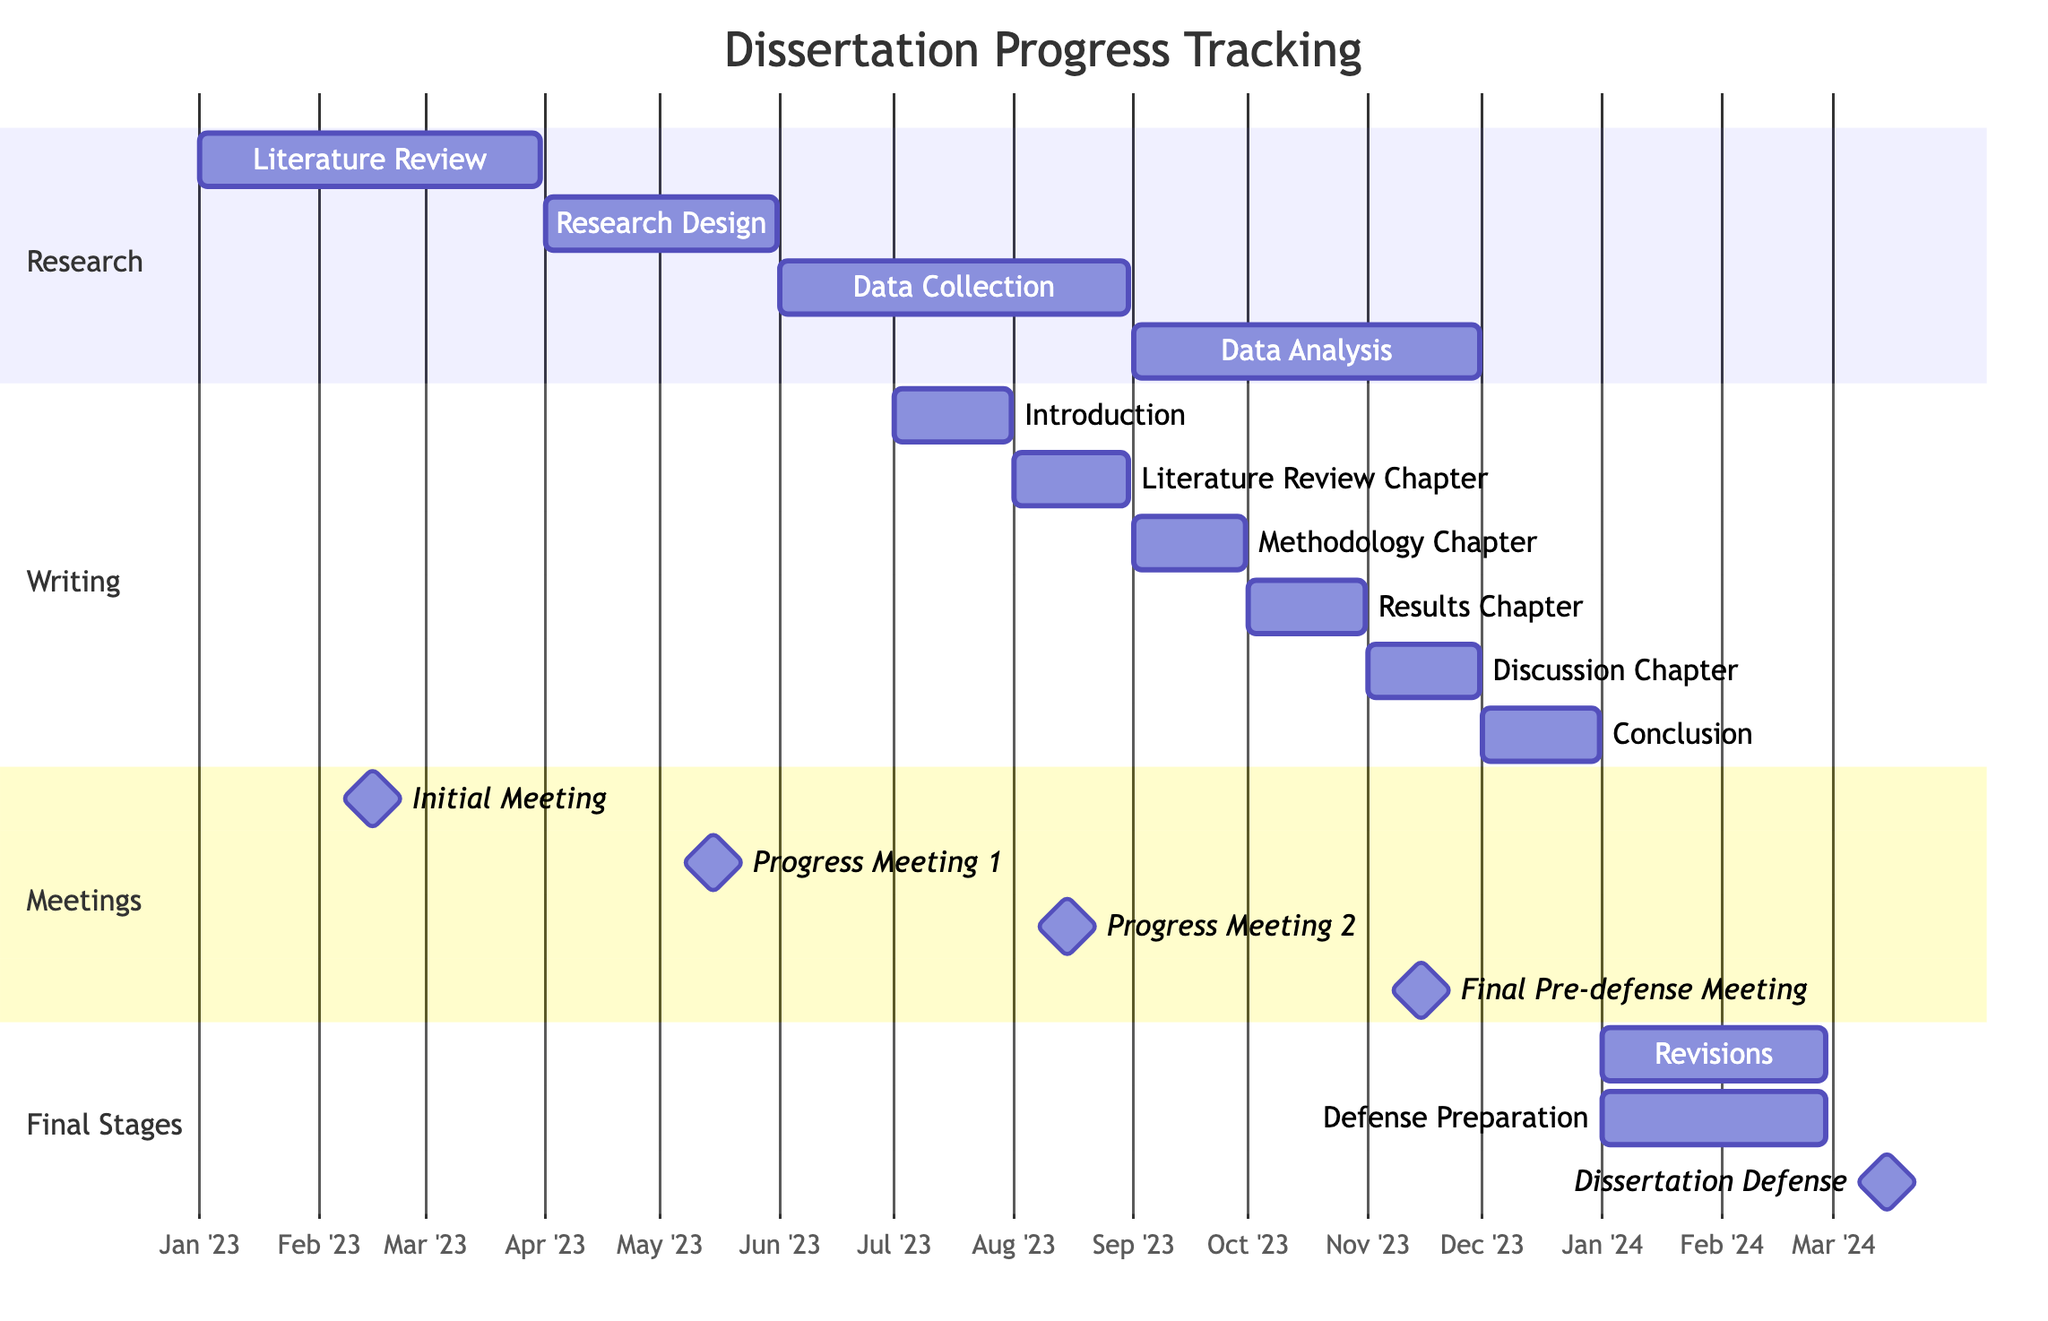What is the end date for the Data Analysis phase? The Data Analysis phase is represented in the Gantt chart, and it begins on September 1, 2023, and ends on November 30, 2023.
Answer: November 30, 2023 How many chapters are being drafted in total? The Gantt chart lists six subtasks under "Drafting Chapters." They are the Introduction, Literature Review Chapter, Methodology Chapter, Results Chapter, Discussion Chapter, and Conclusion, which totals to six chapters.
Answer: 6 When will the Final Pre-defense Meeting occur? The Gantt chart shows the date for the Final Pre-defense Meeting as November 15, 2023, which is indicated as a milestone.
Answer: November 15, 2023 Which phase overlaps with Data Collection? Observing the Gantt chart, the "Drafting Chapters" phase starts on July 1, 2023, and continues until December 31, 2023, overlapping with Data Collection, which spans from June 1, 2023, to August 31, 2023. Thus, the chapter drafting overlaps with the second half of the data collection.
Answer: Drafting Chapters How long is the Revisions phase scheduled to last? The Revisions phase starts on January 1, 2024, and ends on February 28, 2024. This results in a total duration of two months.
Answer: 2 months What is the first task in the Drafting Chapters section? Within the Drafting Chapters section, the first listed task is the Introduction, which is set to begin on July 1, 2023, and conclude on July 31, 2023.
Answer: Introduction Which task has the latest start date in the Writing section? The Conclusion chapter is the last subtask listed in the Writing section, starting on December 1, 2023, and ending on December 31, 2023, making it the task with the latest start date.
Answer: Conclusion What is the date of the Dissertation Defense? The Gantt chart includes a milestone for the Dissertation Defense, which is scheduled for March 15, 2024.
Answer: March 15, 2024 During which month is Progress Meeting 2 scheduled? According to the Gantt chart, Progress Meeting 2 is scheduled for August 15, 2023, which falls within August of 2023.
Answer: August 